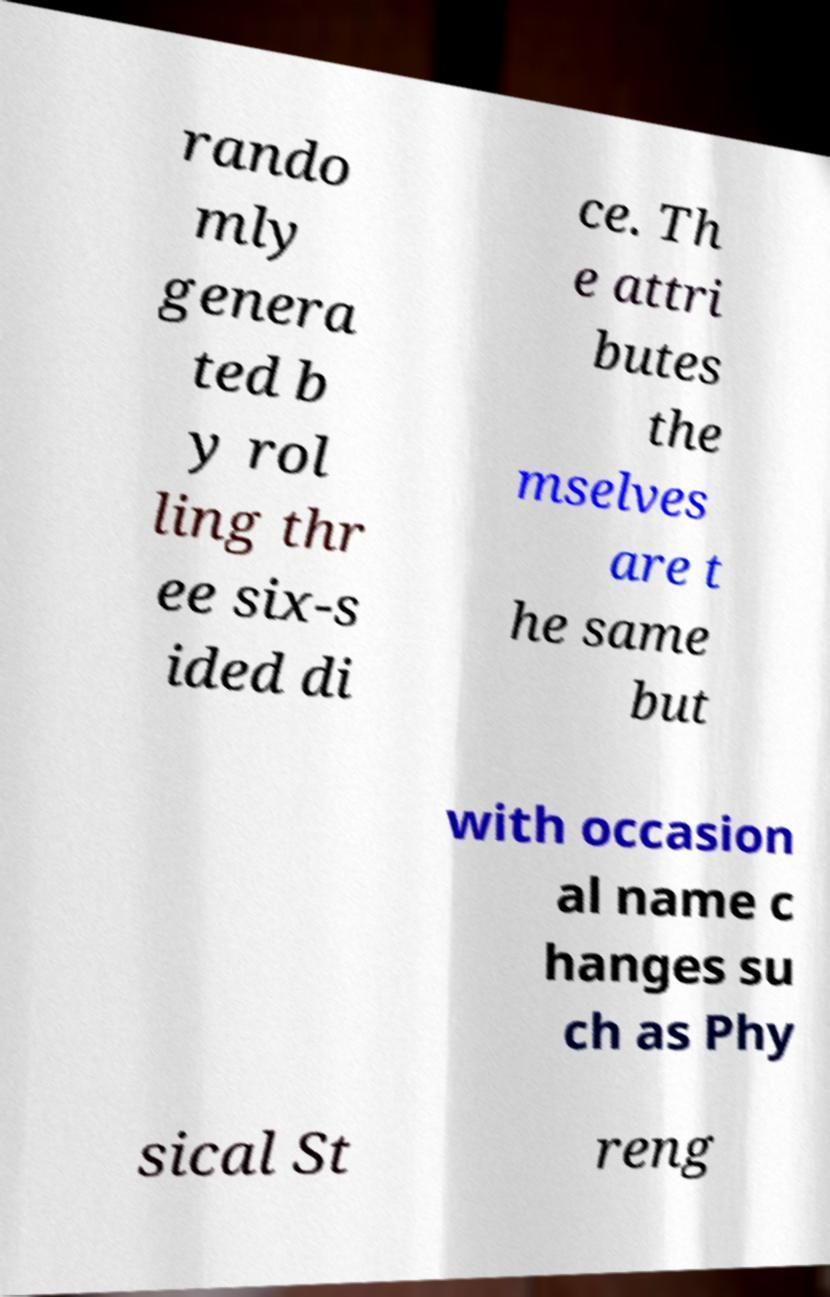There's text embedded in this image that I need extracted. Can you transcribe it verbatim? rando mly genera ted b y rol ling thr ee six-s ided di ce. Th e attri butes the mselves are t he same but with occasion al name c hanges su ch as Phy sical St reng 